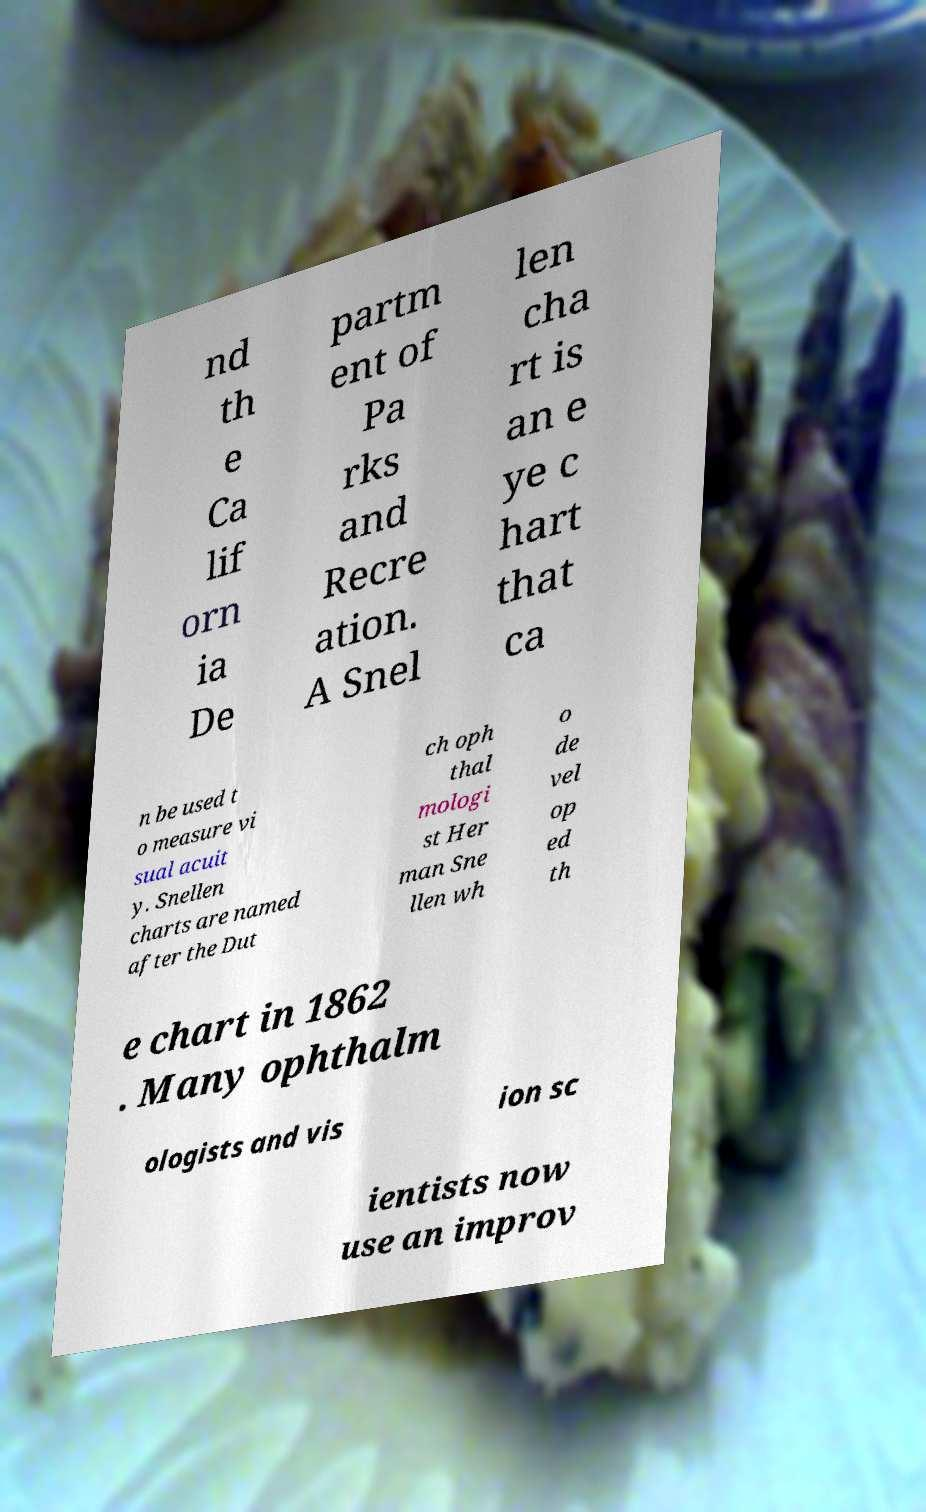Please read and relay the text visible in this image. What does it say? nd th e Ca lif orn ia De partm ent of Pa rks and Recre ation. A Snel len cha rt is an e ye c hart that ca n be used t o measure vi sual acuit y. Snellen charts are named after the Dut ch oph thal mologi st Her man Sne llen wh o de vel op ed th e chart in 1862 . Many ophthalm ologists and vis ion sc ientists now use an improv 